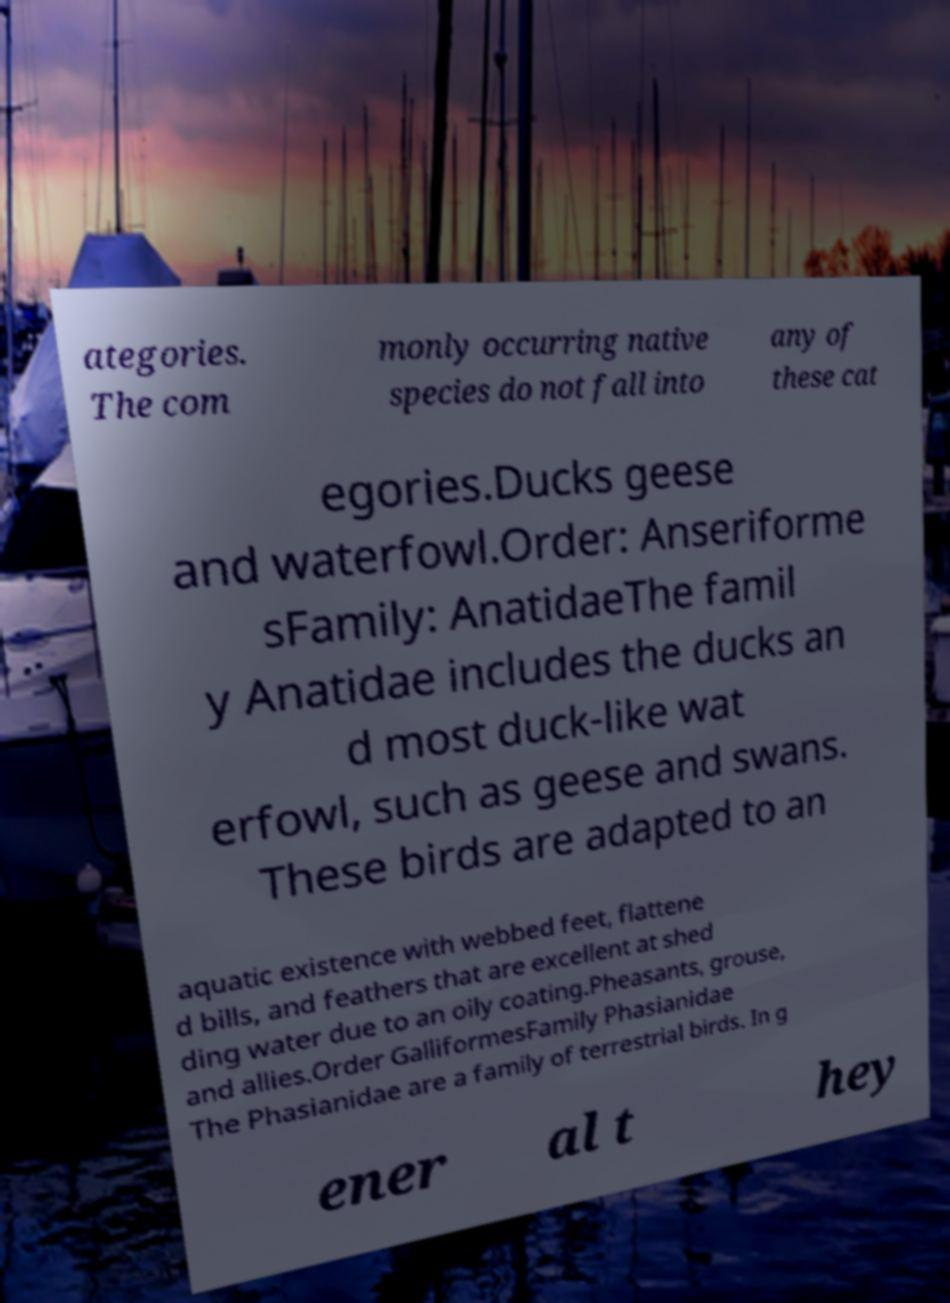Please identify and transcribe the text found in this image. ategories. The com monly occurring native species do not fall into any of these cat egories.Ducks geese and waterfowl.Order: Anseriforme sFamily: AnatidaeThe famil y Anatidae includes the ducks an d most duck-like wat erfowl, such as geese and swans. These birds are adapted to an aquatic existence with webbed feet, flattene d bills, and feathers that are excellent at shed ding water due to an oily coating.Pheasants, grouse, and allies.Order GalliformesFamily Phasianidae The Phasianidae are a family of terrestrial birds. In g ener al t hey 